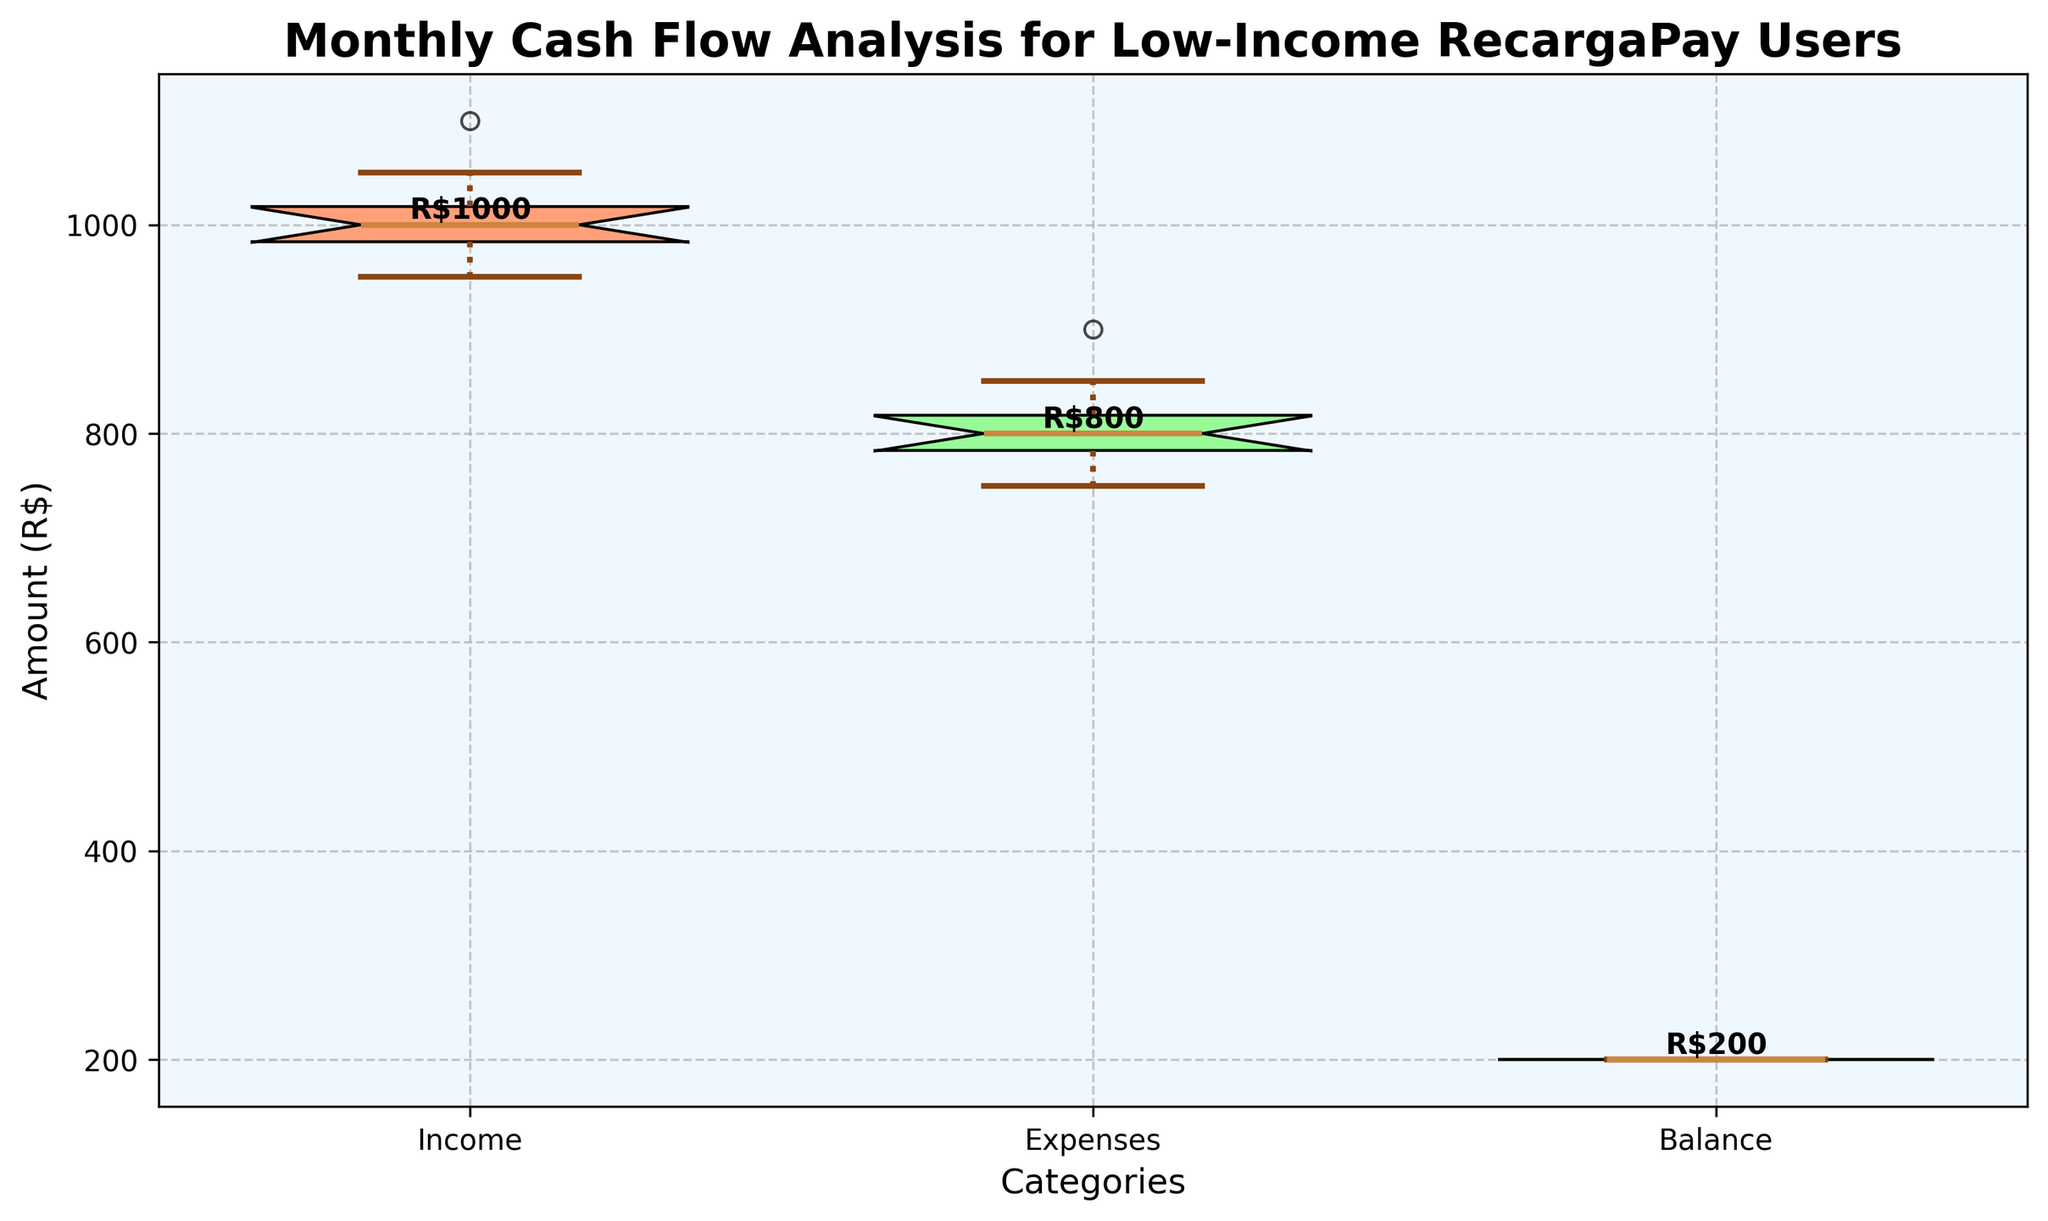What is the title of the figure? The title of the figure is located at the top and usually describes the main subject of the plot.
Answer: Monthly Cash Flow Analysis for Low-Income RecargaPay Users What are the labels on the x-axis? The labels on the x-axis indicate the different categories represented in the data. These labels are located below the x-axis. There are three categories in this figure.
Answer: Income, Expenses, Balance Which category has the highest median value? The median value is marked by a line inside each box. Comparing the medians of Income, Expenses, and Balance, the highest line corresponds to Income.
Answer: Income What are the colors of the boxes representing Income, Expenses, and Balance? Each box has a different color to distinguish between categories. Income is salmon, Expenses is light green, and Balance is light blue.
Answer: Salmon, Light Green, Light Blue How does the variability of Income compare to that of Expenses? Variability is assessed by the spread of the box and whiskers. Looking at the boxes and whiskers, Income and Expenses have similar spreads, indicating similar variability.
Answer: Similar What is the median value for Balance? The median value for Balance is displayed by a bold line inside the Balance box and is usually labeled. In this figure, Balance is consistently R$200 across all months.
Answer: R$200 Which category shows the most consistency in the data? Consistency can be inferred by the narrowest box and shortest whiskers. The Balance category's box is a single line, indicating no spread, hence the most consistent.
Answer: Balance What is the approximate interquartile range (IQR) for Income? The IQR is the range between the first quartile (bottom of the box) and the third quartile (top of the box). For Income, visually estimate the distance between these two lines on the vertical axis.
Answer: Approximately R$50 Do any categories have outliers, and if so, which one(s)? Outliers are shown as points (fliers) outside the whiskers of the box plot. In this figure, there appear to be no outliers in any category.
Answer: None Is there any category with a lower whisker notably longer than the upper whisker? If so, which one? The whiskers represent the spread of the data. For Income and Expenses, the lengths of the whiskers above and below the boxes are about the same. Thus, none have a notably longer lower whisker.
Answer: None 